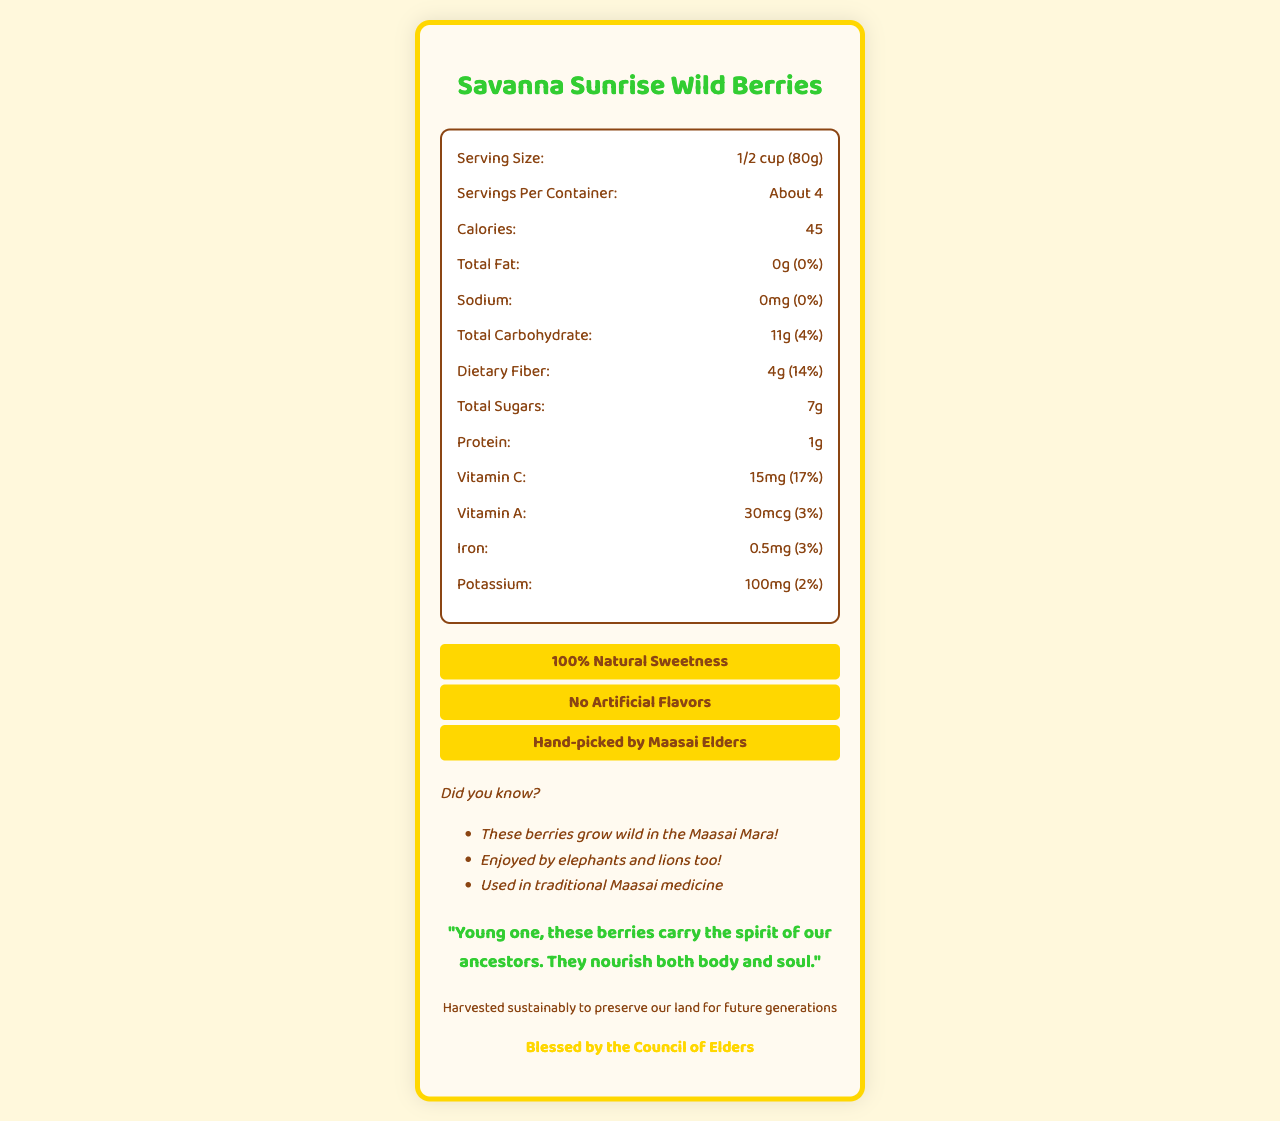what is the serving size? The serving size is clearly stated in the nutrition facts section.
Answer: 1/2 cup (80g) how many servings are in the container? The number of servings per container is listed just below the serving size.
Answer: About 4 how many calories are in one serving? The calorie count per serving is directly stated within the nutrition facts.
Answer: 45 what is the amount of dietary fiber per serving and its daily value percentage? The dietary fiber amount and its daily value percentage are listed in the nutrition facts.
Answer: 4g (14%) what is the amount of vitamin C per serving and its daily value percentage? The amount of vitamin C and its daily value percentage are listed in the nutrition facts.
Answer: 15mg (17%) which feature is NOT listed in the special features of the product? A. 100% Natural Sweetness B. Rich in Protein C. No Artificial Flavors D. Hand-picked by Maasai Elders The special features listed are 100% Natural Sweetness, No Artificial Flavors, and Hand-picked by Maasai Elders. "Rich in Protein" is not among these features.
Answer: B. Rich in Protein which color is used as the primary color in the label's design? A. #8B4513 B. #FFD700 C. #32CD32 The primary color in the label's design is #8B4513 according to the color scheme information.
Answer: A. #8B4513 is there any added sugar in this product? The nutrition facts indicate that there is 0g of added sugars in the product.
Answer: No describe the entire document briefly. The document comprises nutritional information, highlights special aspects of the berries, includes cultural references, and advocates for sustainability, all wrapped in a lively and colorful design.
Answer: The document is a colorful Nutrition Facts Label for "Savanna Sunrise Wild Berries". It includes serving size, nutritional content per serving, special features, fun facts, elder wisdom, sustainability notes, and an approval from the Council of Elders. The label highlights the natural sweetness and vitamins of the wild berries, emphasizing their cultural significance and sustainable harvesting. are the wild berries used in traditional Maasai medicine? It's stated in the fun facts section that the berries are used in traditional Maasai medicine.
Answer: Yes how much potassium is in one serving? The nutrition facts indicate that each serving contains 100mg of potassium.
Answer: 100mg how many grams of total carbohydrate are there per serving? The amount of total carbohydrates per serving is listed as 11g in the nutrition facts.
Answer: 11g what is the calorie content for the entire container? Each serving has 45 calories, and with about 4 servings per container, the total is approximately 180 calories. The calculation is 45 calories x 4 servings.
Answer: 180 calories what is the name of the product? The product name is displayed prominently at the top of the label.
Answer: Savanna Sunrise Wild Berries is the product blessed by the Council of Elders? The document states that the product is "Blessed by the Council of Elders".
Answer: Yes where do these berries grow? The fun facts section indicates that these berries grow wild in the Maasai Mara.
Answer: Maasai Mara 